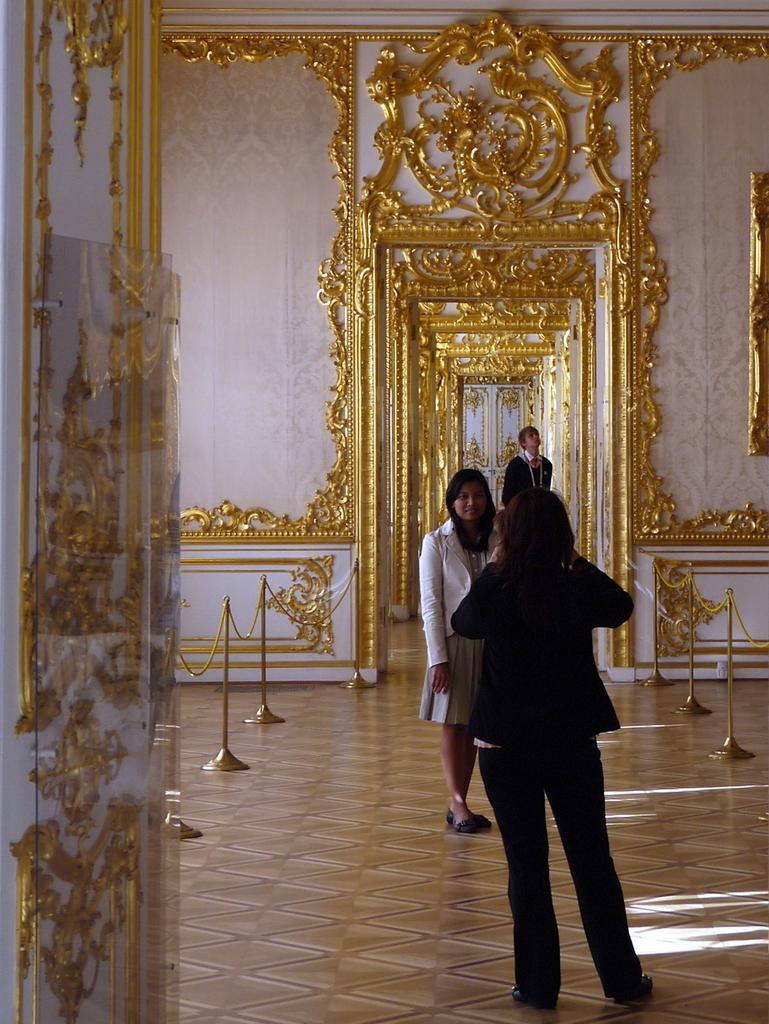Describe this image in one or two sentences. In this I can see few people are standing, looks like inner view of a room and I can see carvings on the wall, it looks like a designer wall 